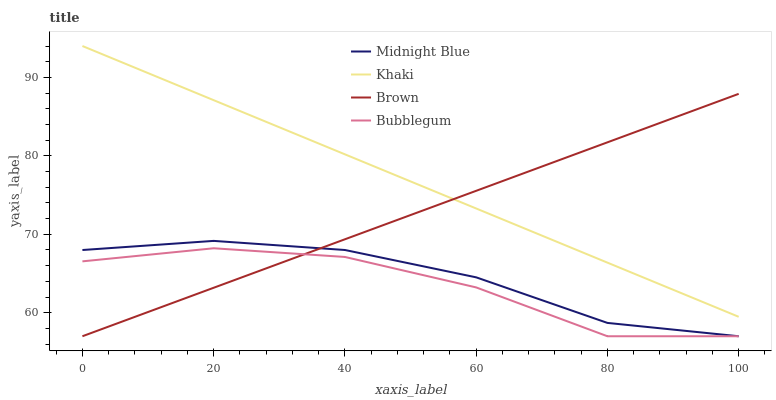Does Bubblegum have the minimum area under the curve?
Answer yes or no. Yes. Does Khaki have the maximum area under the curve?
Answer yes or no. Yes. Does Midnight Blue have the minimum area under the curve?
Answer yes or no. No. Does Midnight Blue have the maximum area under the curve?
Answer yes or no. No. Is Brown the smoothest?
Answer yes or no. Yes. Is Bubblegum the roughest?
Answer yes or no. Yes. Is Khaki the smoothest?
Answer yes or no. No. Is Khaki the roughest?
Answer yes or no. No. Does Brown have the lowest value?
Answer yes or no. Yes. Does Khaki have the lowest value?
Answer yes or no. No. Does Khaki have the highest value?
Answer yes or no. Yes. Does Midnight Blue have the highest value?
Answer yes or no. No. Is Bubblegum less than Khaki?
Answer yes or no. Yes. Is Khaki greater than Midnight Blue?
Answer yes or no. Yes. Does Khaki intersect Brown?
Answer yes or no. Yes. Is Khaki less than Brown?
Answer yes or no. No. Is Khaki greater than Brown?
Answer yes or no. No. Does Bubblegum intersect Khaki?
Answer yes or no. No. 